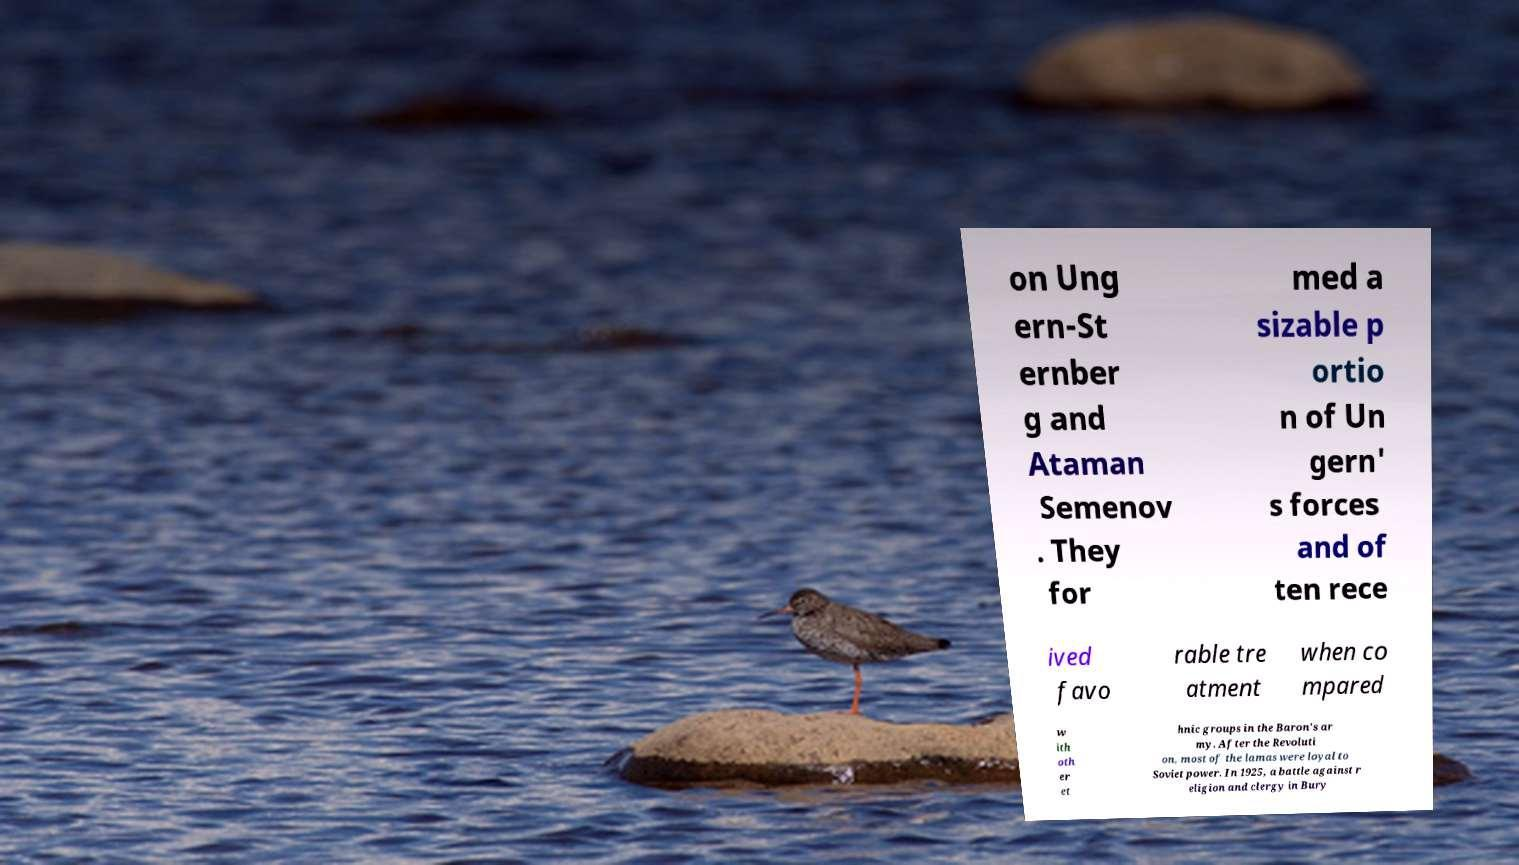Please identify and transcribe the text found in this image. on Ung ern-St ernber g and Ataman Semenov . They for med a sizable p ortio n of Un gern' s forces and of ten rece ived favo rable tre atment when co mpared w ith oth er et hnic groups in the Baron's ar my. After the Revoluti on, most of the lamas were loyal to Soviet power. In 1925, a battle against r eligion and clergy in Bury 